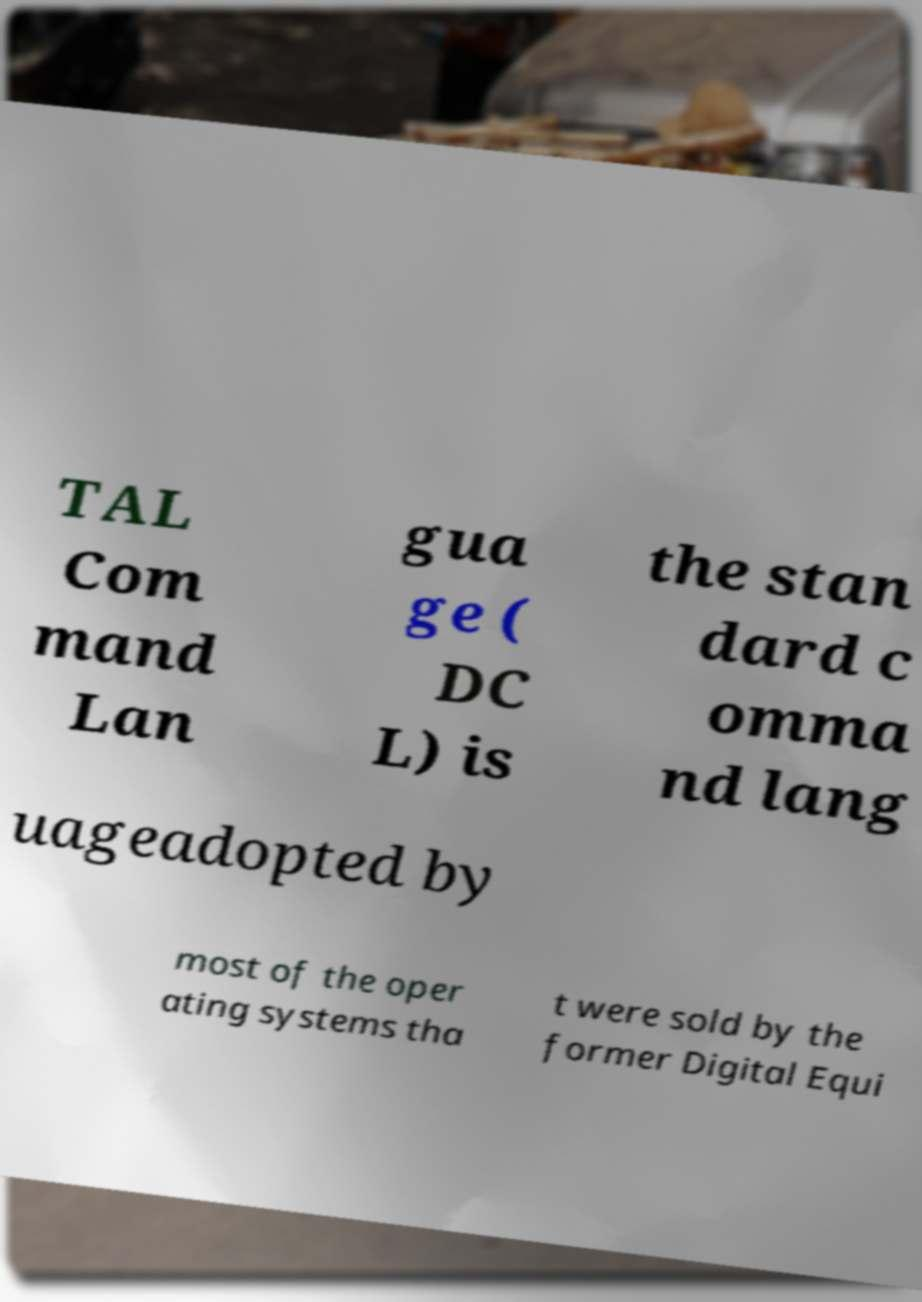Please read and relay the text visible in this image. What does it say? TAL Com mand Lan gua ge ( DC L) is the stan dard c omma nd lang uageadopted by most of the oper ating systems tha t were sold by the former Digital Equi 